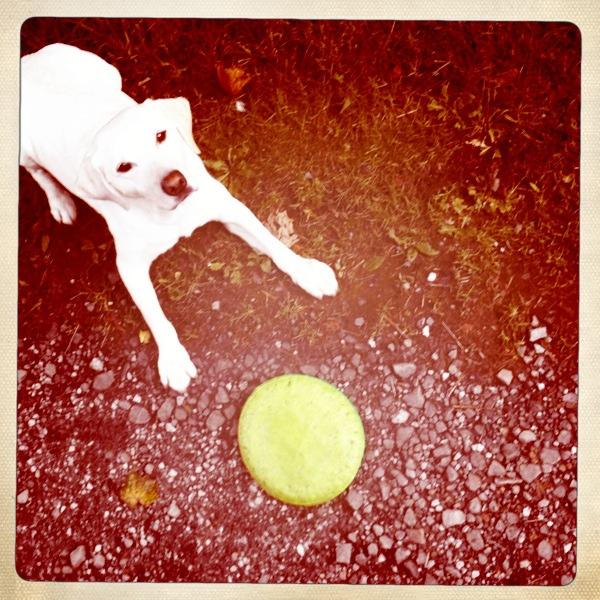How many dogs?
Be succinct. 1. What color is the frisbee?
Write a very short answer. Yellow. Is this a dog?
Answer briefly. Yes. How does this animal move?
Answer briefly. On fours. 